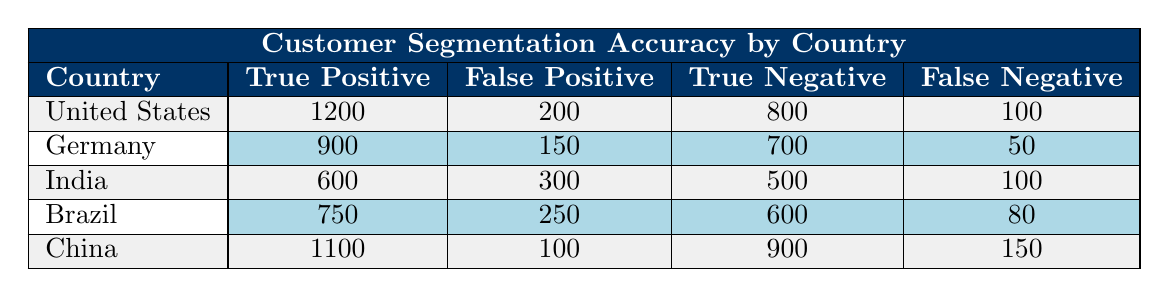What is the True Positive rate for Germany? The True Positive rate is the number of True Positives divided by the total number of actual positives (True Positives + False Negatives). For Germany, this is calculated as 900 / (900 + 50) = 900 / 950 = 0.947 or 94.7%.
Answer: 94.7% Which country has the highest number of True Negatives? By examining the True Negative column, the United States has 800, Germany has 700, India has 500, Brazil has 600, and China has 900. The highest value is 900 from China.
Answer: China What is the total number of False Positives across all countries? Adding the False Positives for each country gives: 200 + 150 + 300 + 250 + 100 = 1000.
Answer: 1000 Are there more True Positives in the United States than in India? The True Positive for the United States is 1200 and for India, it is 600. Since 1200 is greater than 600, the statement is true.
Answer: Yes What is the difference between True Positives and False Negatives for Brazil? The True Positives in Brazil are 750 and the False Negatives are 80. The difference is calculated as 750 - 80 = 670.
Answer: 670 Which country has the lowest ratio of False Positives to True Positives? The ratio of False Positives to True Positives for each country is calculated as: United States (200/1200 = 0.167), Germany (150/900 = 0.167), India (300/600 = 0.5), Brazil (250/750 = 0.333), China (100/1100 = 0.091). The lowest ratio is 0.091 for China.
Answer: China What is the average number of False Negatives across all countries? The total number of False Negatives is 100 + 50 + 100 + 80 + 150 = 480. There are 5 countries, so the average is 480 / 5 = 96.
Answer: 96 Is the total of True Positives greater than the total of True Negatives across all countries? Total True Positives = 1200 + 900 + 600 + 750 + 1100 = 4050. Total True Negatives = 800 + 700 + 500 + 600 + 900 = 3500. Since 4050 is greater than 3500, the statement is true.
Answer: Yes 